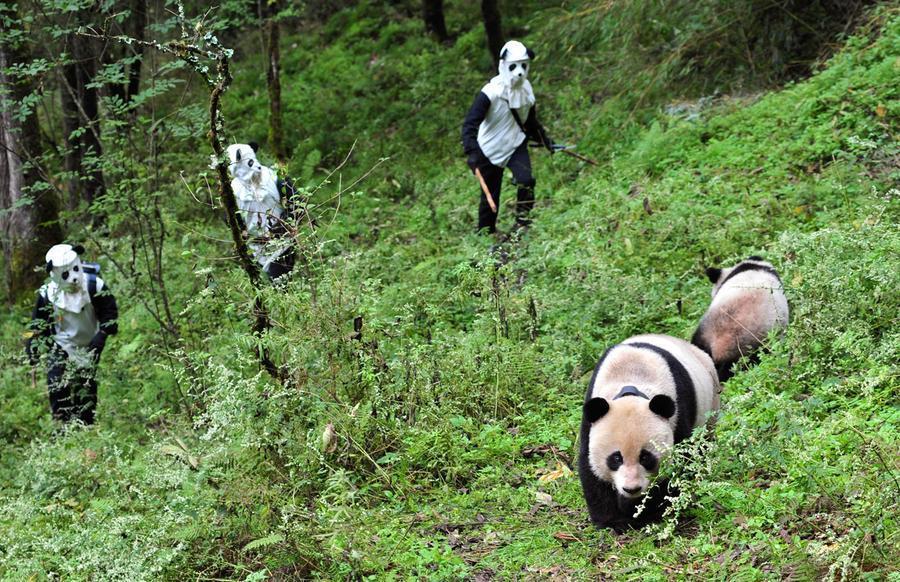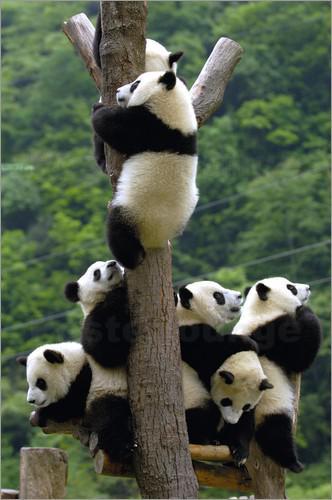The first image is the image on the left, the second image is the image on the right. Examine the images to the left and right. Is the description "Each image contains only one panda, and one image shows a panda with its paws draped over something for support." accurate? Answer yes or no. No. The first image is the image on the left, the second image is the image on the right. Analyze the images presented: Is the assertion "There is at least one panda up in a tree." valid? Answer yes or no. Yes. 